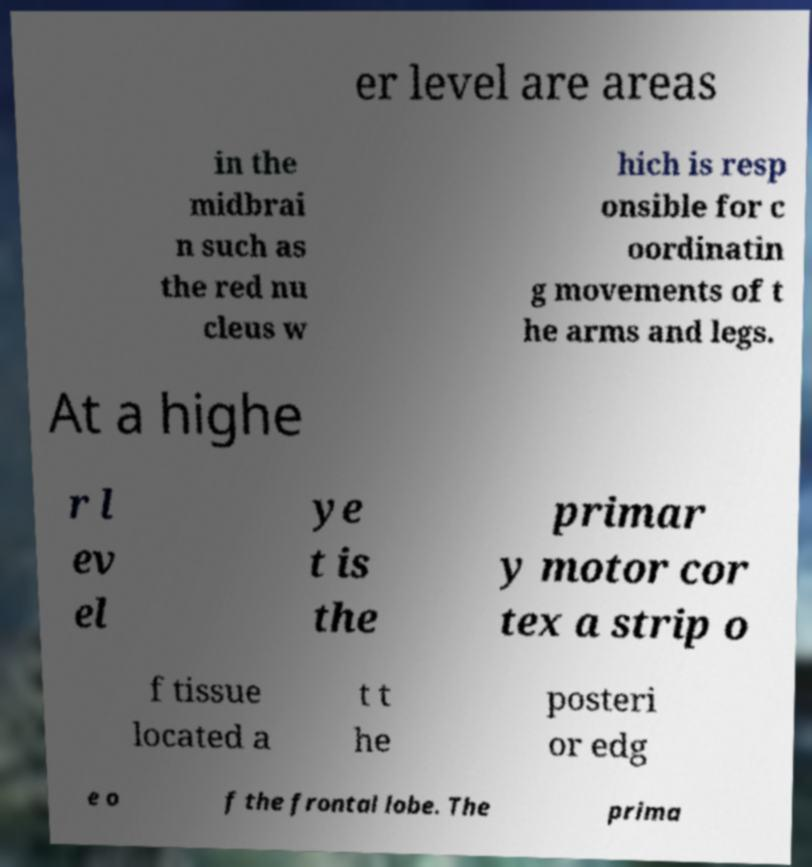Please identify and transcribe the text found in this image. er level are areas in the midbrai n such as the red nu cleus w hich is resp onsible for c oordinatin g movements of t he arms and legs. At a highe r l ev el ye t is the primar y motor cor tex a strip o f tissue located a t t he posteri or edg e o f the frontal lobe. The prima 